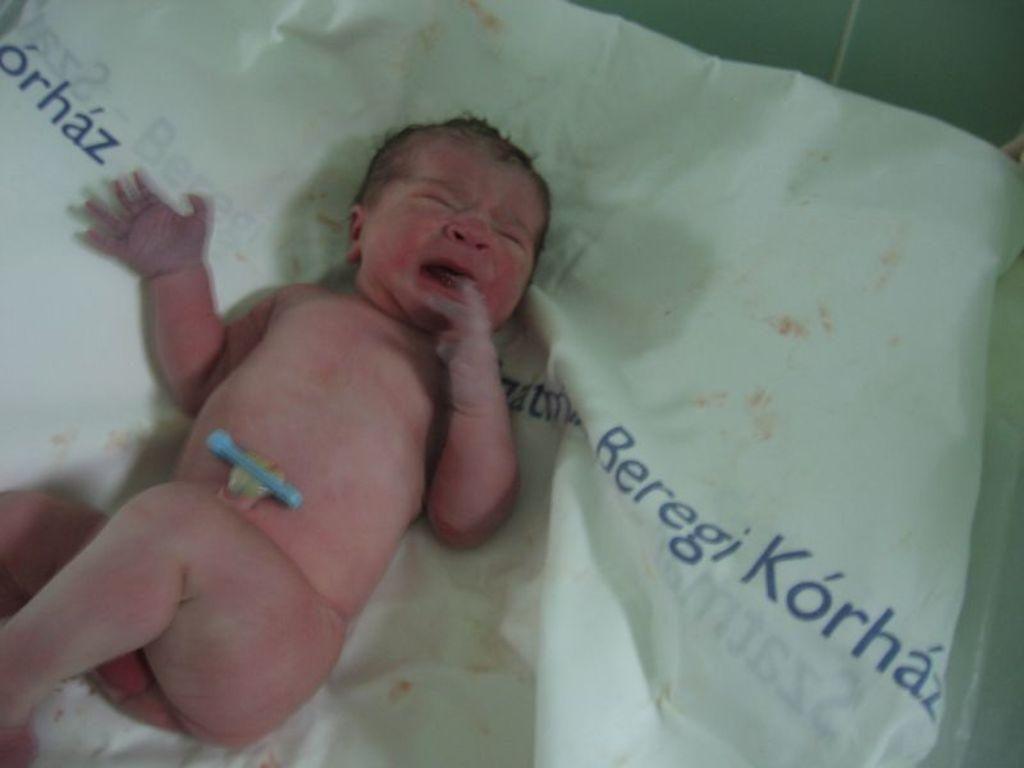What is the main subject of the picture? The main subject of the picture is a baby. Where is the baby located in the picture? The baby is on a white cloth. What else can be seen in the picture besides the baby? There is text visible in the picture. What type of machine can be heard making noise in the background of the image? There is no machine or noise present in the image; it only features a baby on a white cloth with visible text. 